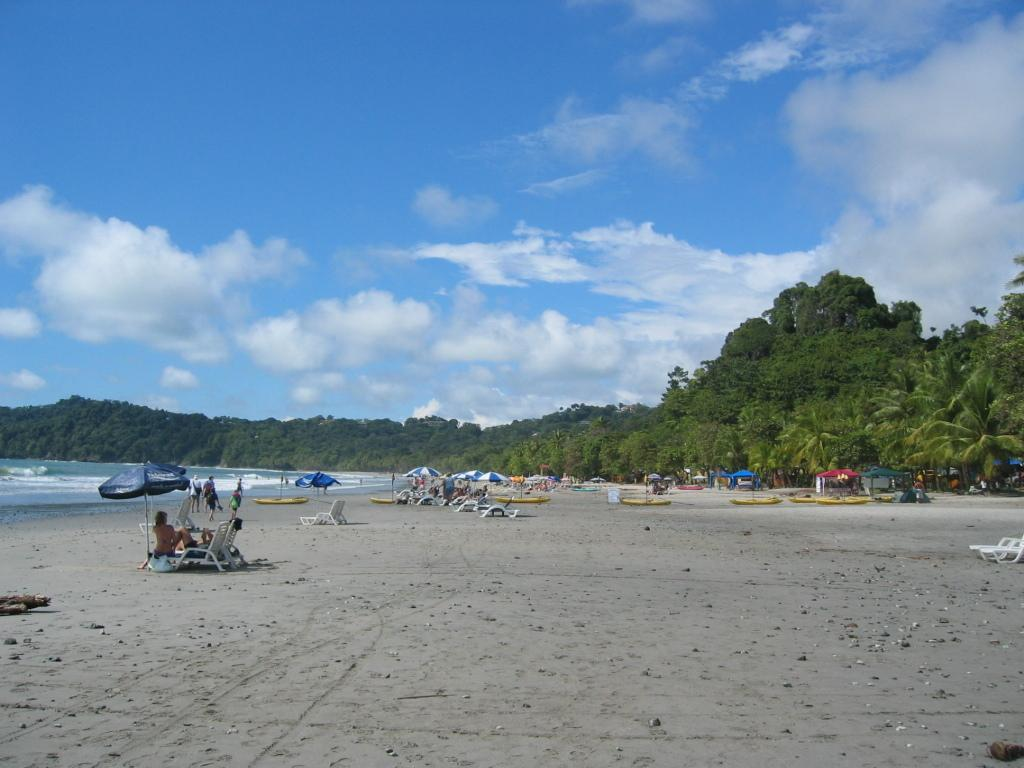What type of natural environment is depicted in the image? There is a beach and an ocean in the image. What can be seen behind the beach? Trees are visible behind the beach. How would you describe the sky in the image? The sky is blue with clouds. Can you tell me how many grapes are on the beach in the image? There are no grapes present on the beach in the image. Is there a maid serving cheese on the beach in the image? There is no maid or cheese present on the beach in the image. 